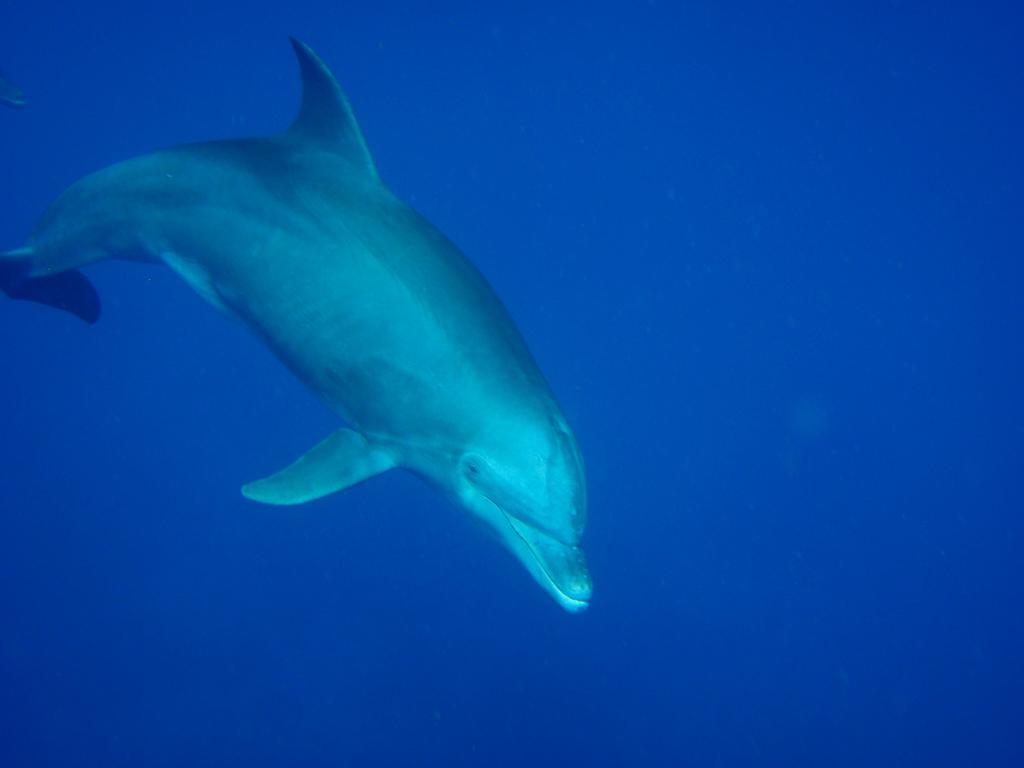What animal is the main subject of the image? There is a shark in the image. Where is the shark located? The shark is in the water. What color is the background of the image? The background of the image is blue. How many times does the shark kick the ball in the image? There is no ball present in the image, and therefore no kicking activity can be observed. 